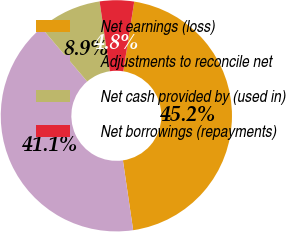<chart> <loc_0><loc_0><loc_500><loc_500><pie_chart><fcel>Net earnings (loss)<fcel>Adjustments to reconcile net<fcel>Net cash provided by (used in)<fcel>Net borrowings (repayments)<nl><fcel>45.21%<fcel>41.1%<fcel>8.9%<fcel>4.79%<nl></chart> 